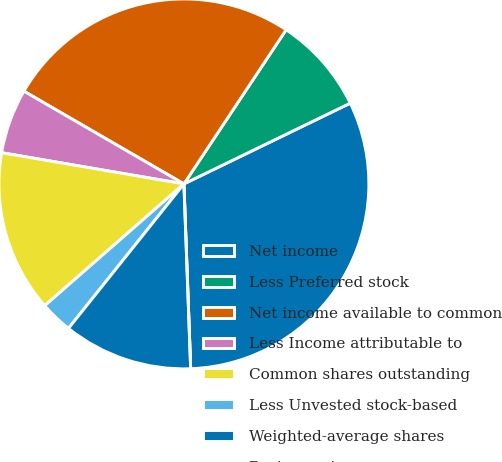Convert chart to OTSL. <chart><loc_0><loc_0><loc_500><loc_500><pie_chart><fcel>Net income<fcel>Less Preferred stock<fcel>Net income available to common<fcel>Less Income attributable to<fcel>Common shares outstanding<fcel>Less Unvested stock-based<fcel>Weighted-average shares<fcel>Basic earnings per common<nl><fcel>31.61%<fcel>8.49%<fcel>25.96%<fcel>5.66%<fcel>14.14%<fcel>2.83%<fcel>11.31%<fcel>0.0%<nl></chart> 